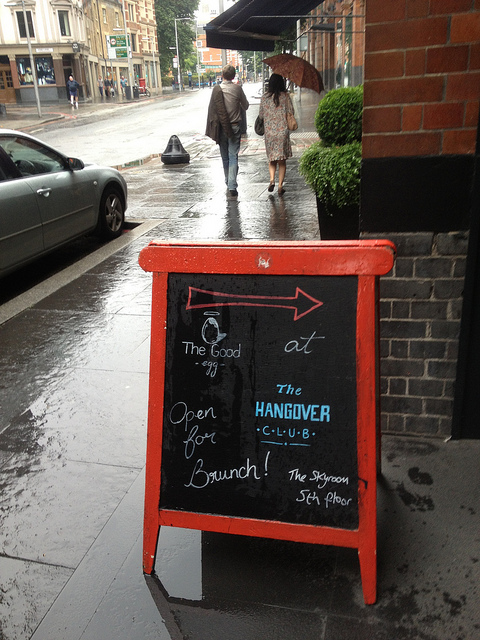Please identify all text content in this image. HANGOVER The Good at The Brunch 5th floor skyroom The egg for Open CLUB 